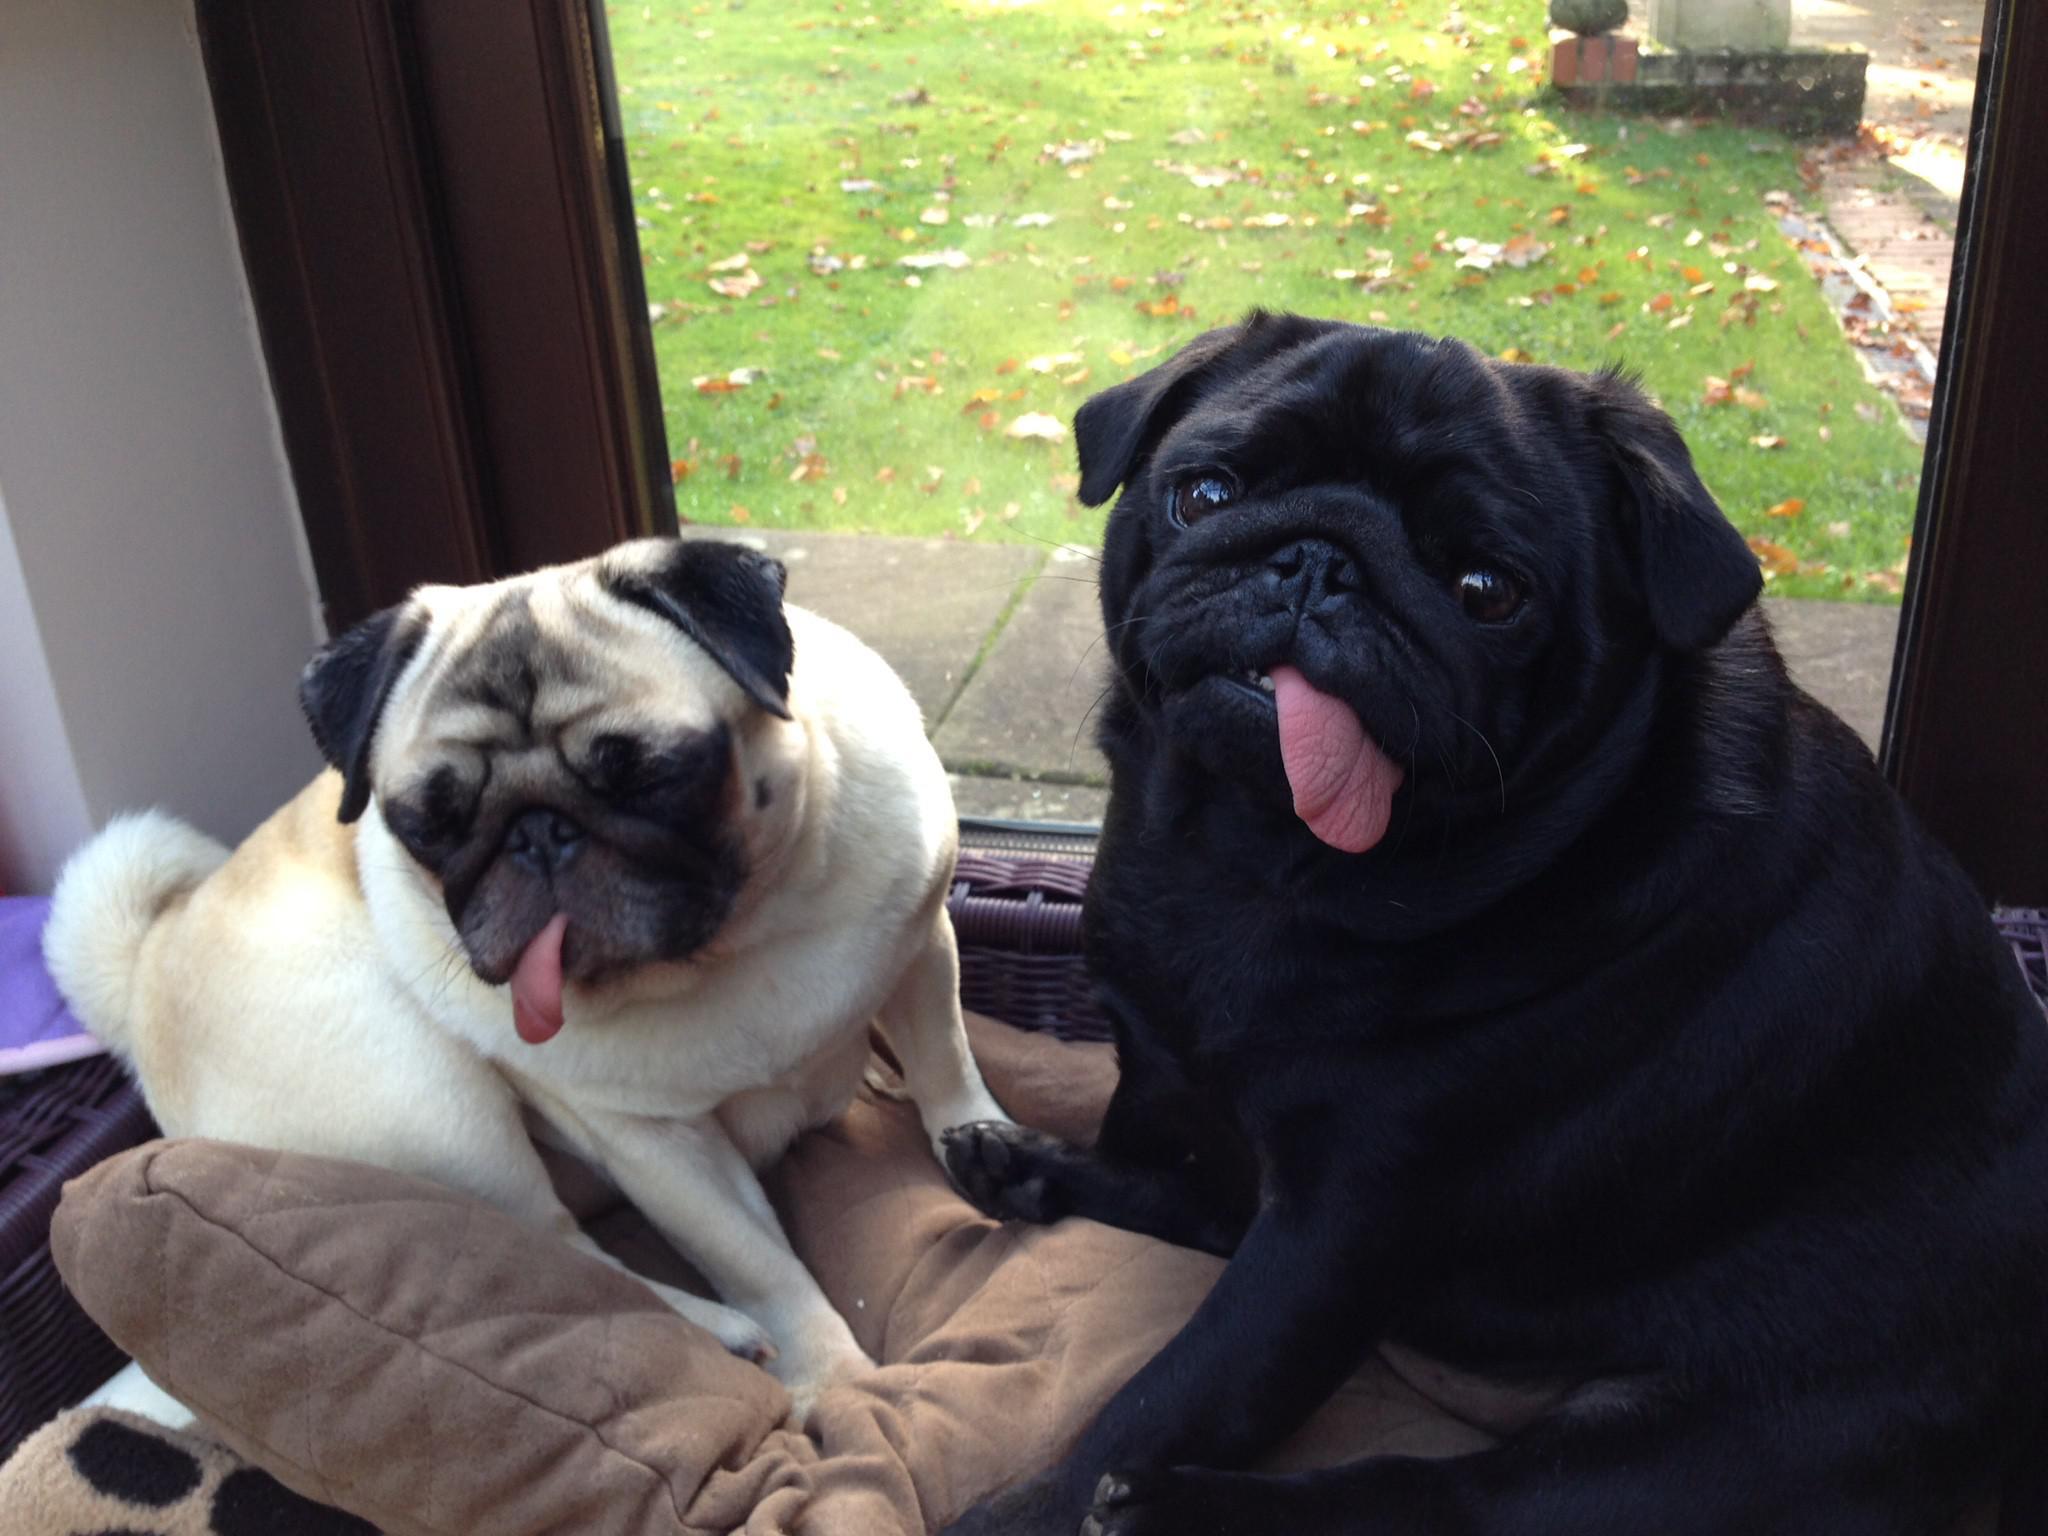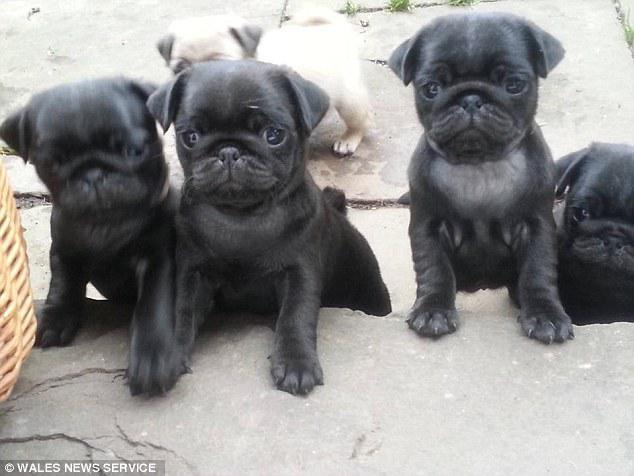The first image is the image on the left, the second image is the image on the right. For the images shown, is this caption "There is a single black dog looking at the camera." true? Answer yes or no. No. The first image is the image on the left, the second image is the image on the right. Examine the images to the left and right. Is the description "We've got three pups here." accurate? Answer yes or no. No. 